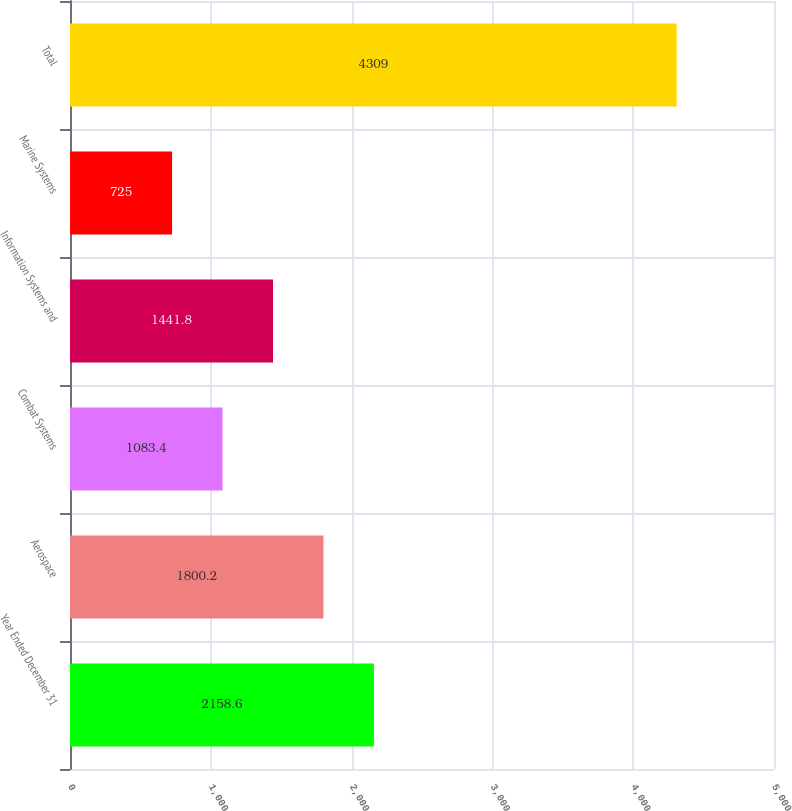<chart> <loc_0><loc_0><loc_500><loc_500><bar_chart><fcel>Year Ended December 31<fcel>Aerospace<fcel>Combat Systems<fcel>Information Systems and<fcel>Marine Systems<fcel>Total<nl><fcel>2158.6<fcel>1800.2<fcel>1083.4<fcel>1441.8<fcel>725<fcel>4309<nl></chart> 